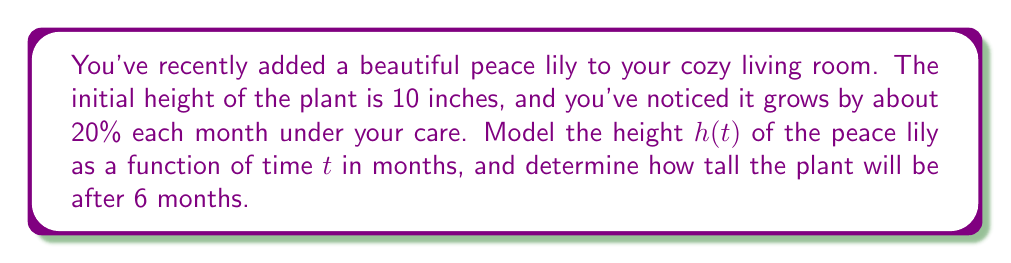Can you answer this question? Let's approach this step-by-step:

1) The growth of the peace lily can be modeled using an exponential function, as it grows by a fixed percentage each month.

2) The general form of an exponential growth function is:
   $$h(t) = a \cdot b^t$$
   where $a$ is the initial value, $b$ is the growth factor, and $t$ is the time.

3) We know the initial height is 10 inches, so $a = 10$.

4) The plant grows by 20% each month, which means it multiplies by 1.20 each month. So $b = 1.20$.

5) Our function is therefore:
   $$h(t) = 10 \cdot (1.20)^t$$

6) To find the height after 6 months, we substitute $t = 6$:
   $$h(6) = 10 \cdot (1.20)^6$$

7) Calculate:
   $$h(6) = 10 \cdot 2.98598 = 29.8598$$

8) Round to two decimal places: 29.86 inches.
Answer: After 6 months, the peace lily will be approximately 29.86 inches tall. 